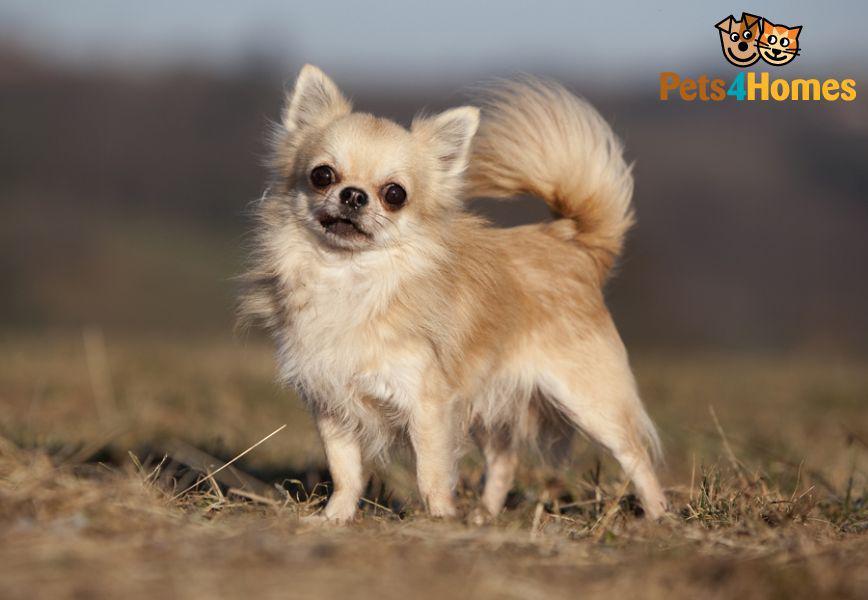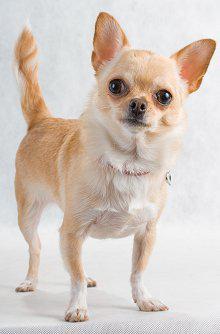The first image is the image on the left, the second image is the image on the right. Evaluate the accuracy of this statement regarding the images: "At least one dog is sitting.". Is it true? Answer yes or no. No. 